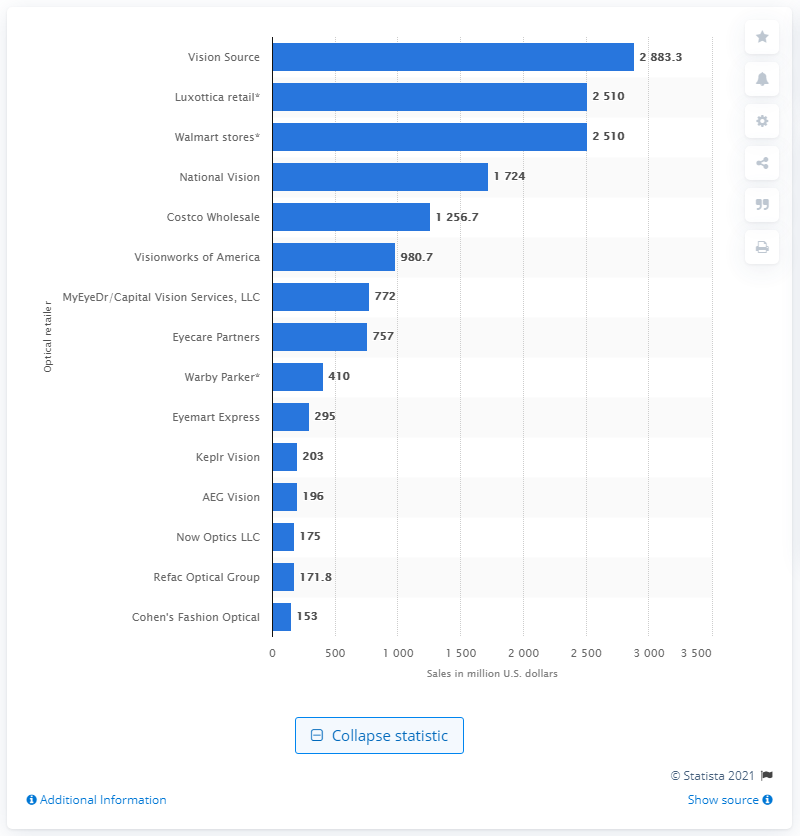Outline some significant characteristics in this image. In 2019, Visionworks of America's sales reached a total of 980.7 million dollars. Visionworks of America was the sixth ranked optical retailer in the United States in 2019. 